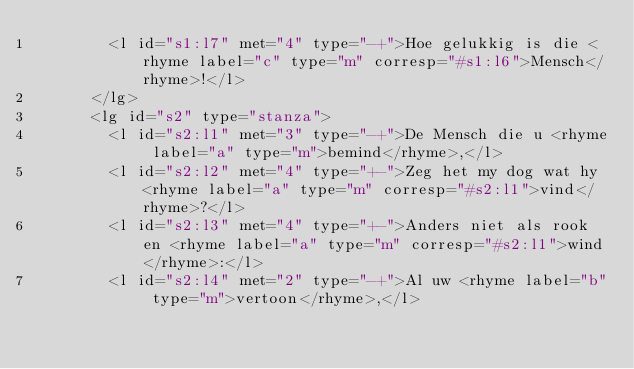<code> <loc_0><loc_0><loc_500><loc_500><_XML_>        <l id="s1:l7" met="4" type="-+">Hoe gelukkig is die <rhyme label="c" type="m" corresp="#s1:l6">Mensch</rhyme>!</l>
      </lg>
      <lg id="s2" type="stanza">
        <l id="s2:l1" met="3" type="-+">De Mensch die u <rhyme label="a" type="m">bemind</rhyme>,</l>
        <l id="s2:l2" met="4" type="+-">Zeg het my dog wat hy <rhyme label="a" type="m" corresp="#s2:l1">vind</rhyme>?</l>
        <l id="s2:l3" met="4" type="+-">Anders niet als rook en <rhyme label="a" type="m" corresp="#s2:l1">wind</rhyme>:</l>
        <l id="s2:l4" met="2" type="-+">Al uw <rhyme label="b" type="m">vertoon</rhyme>,</l></code> 